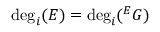<formula> <loc_0><loc_0><loc_500><loc_500>\deg _ { i } ( E ) = \deg _ { i } ^ { E } G )</formula> 